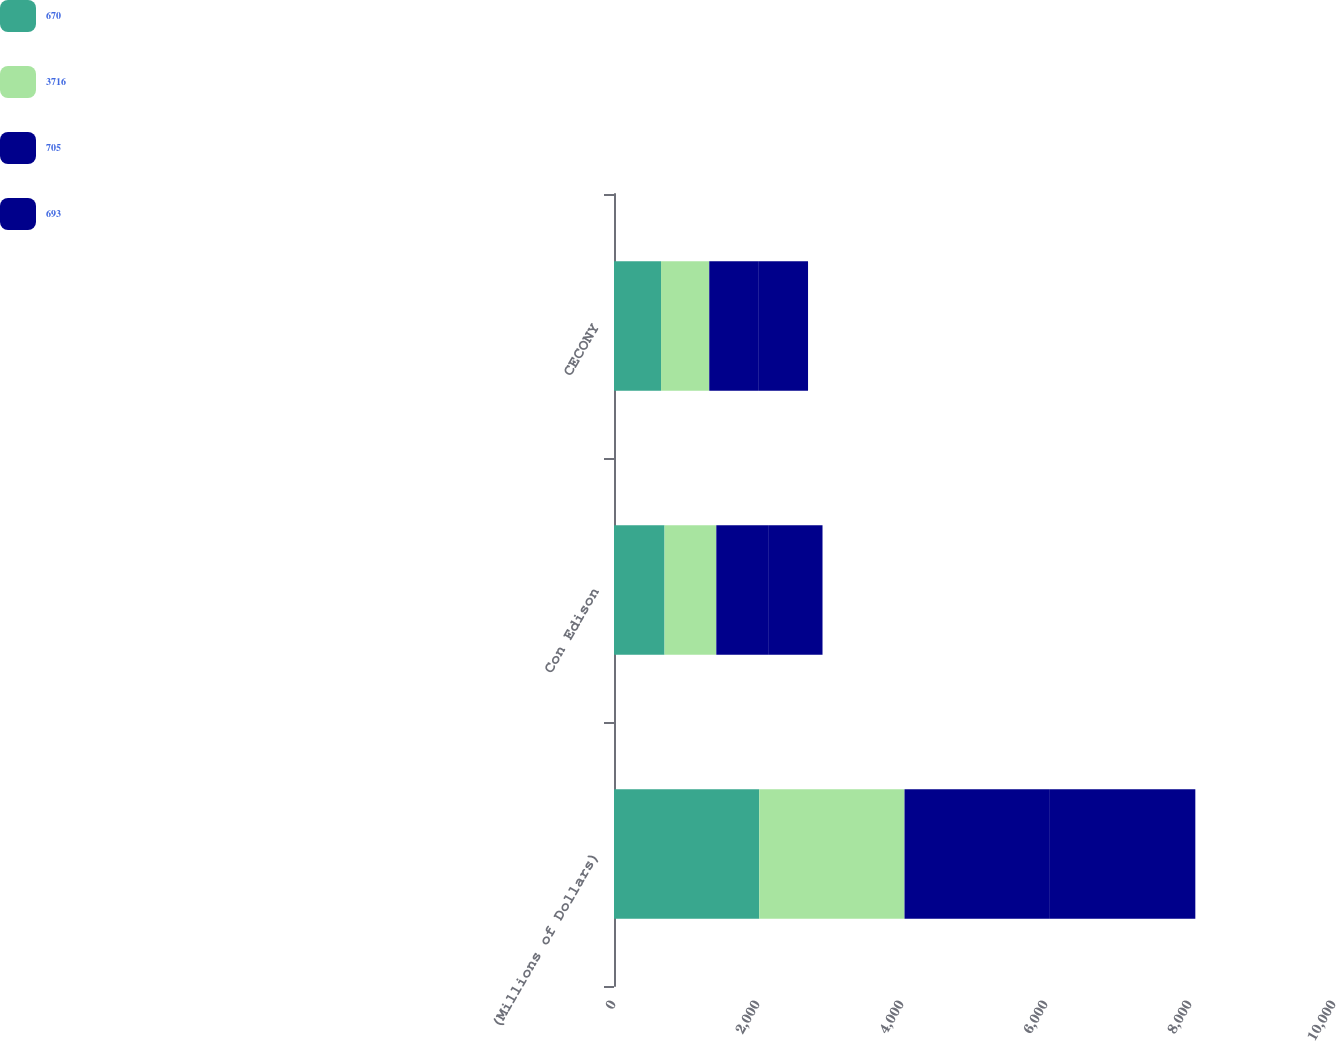<chart> <loc_0><loc_0><loc_500><loc_500><stacked_bar_chart><ecel><fcel>(Millions of Dollars)<fcel>Con Edison<fcel>CECONY<nl><fcel>670<fcel>2017<fcel>702<fcel>653<nl><fcel>3716<fcel>2018<fcel>719<fcel>670<nl><fcel>705<fcel>2019<fcel>730<fcel>679<nl><fcel>693<fcel>2020<fcel>745<fcel>693<nl></chart> 